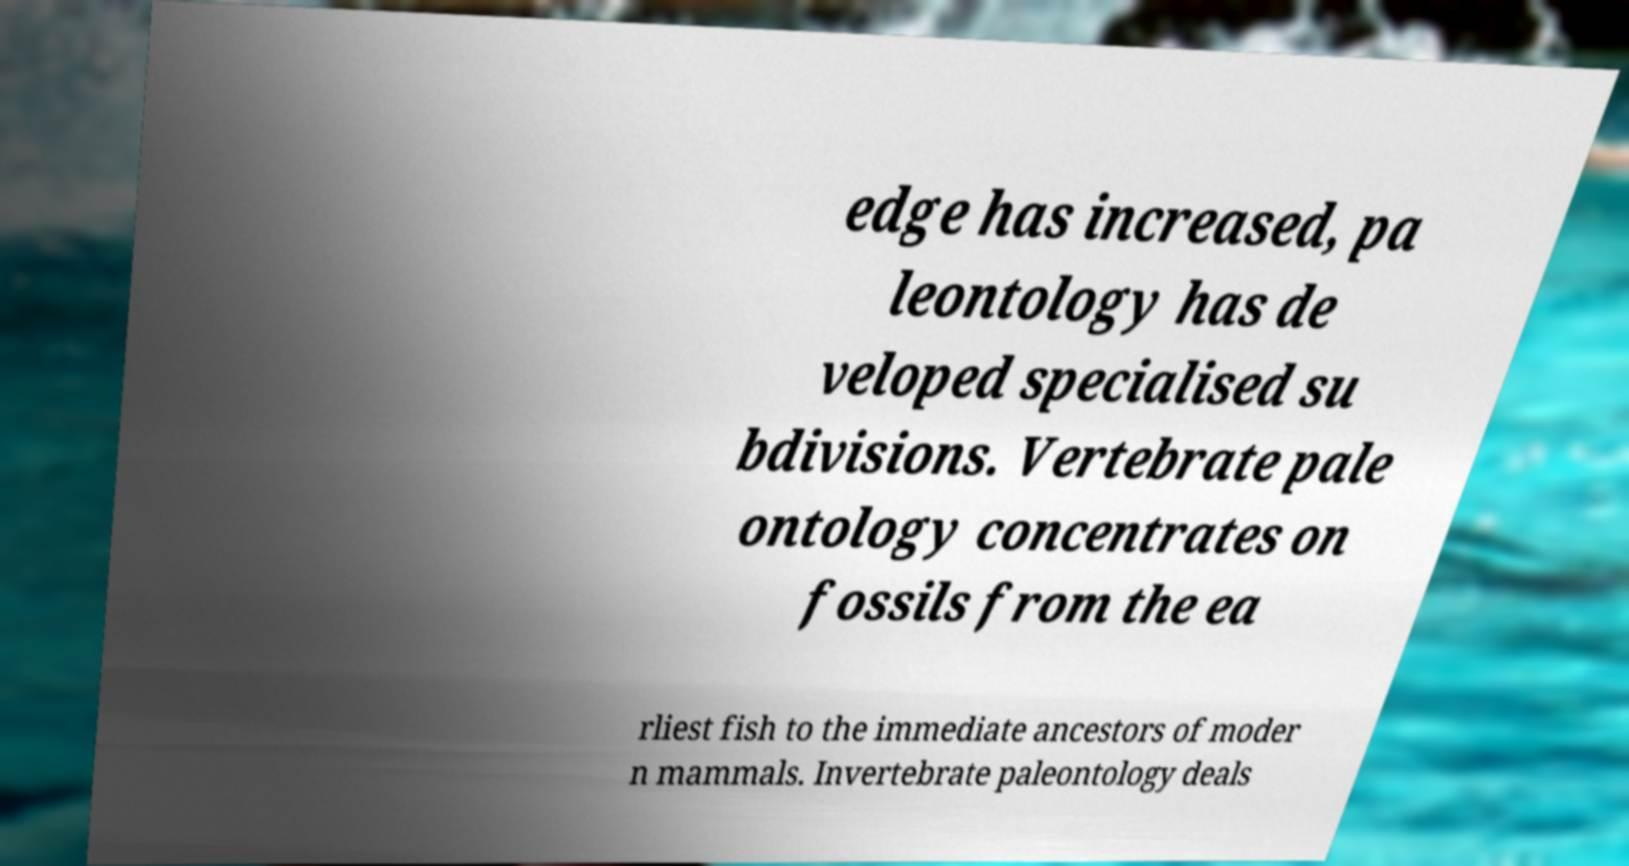For documentation purposes, I need the text within this image transcribed. Could you provide that? edge has increased, pa leontology has de veloped specialised su bdivisions. Vertebrate pale ontology concentrates on fossils from the ea rliest fish to the immediate ancestors of moder n mammals. Invertebrate paleontology deals 